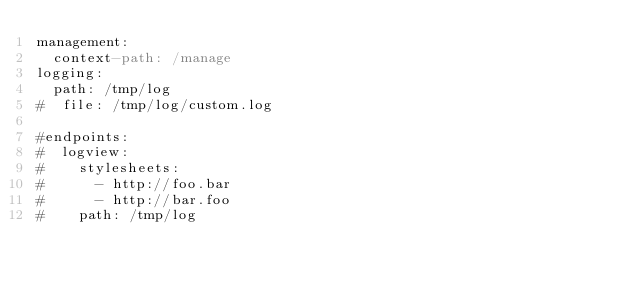<code> <loc_0><loc_0><loc_500><loc_500><_YAML_>management:
  context-path: /manage
logging:
  path: /tmp/log
#  file: /tmp/log/custom.log

#endpoints:
#  logview:
#    stylesheets:
#      - http://foo.bar
#      - http://bar.foo
#    path: /tmp/log
</code> 